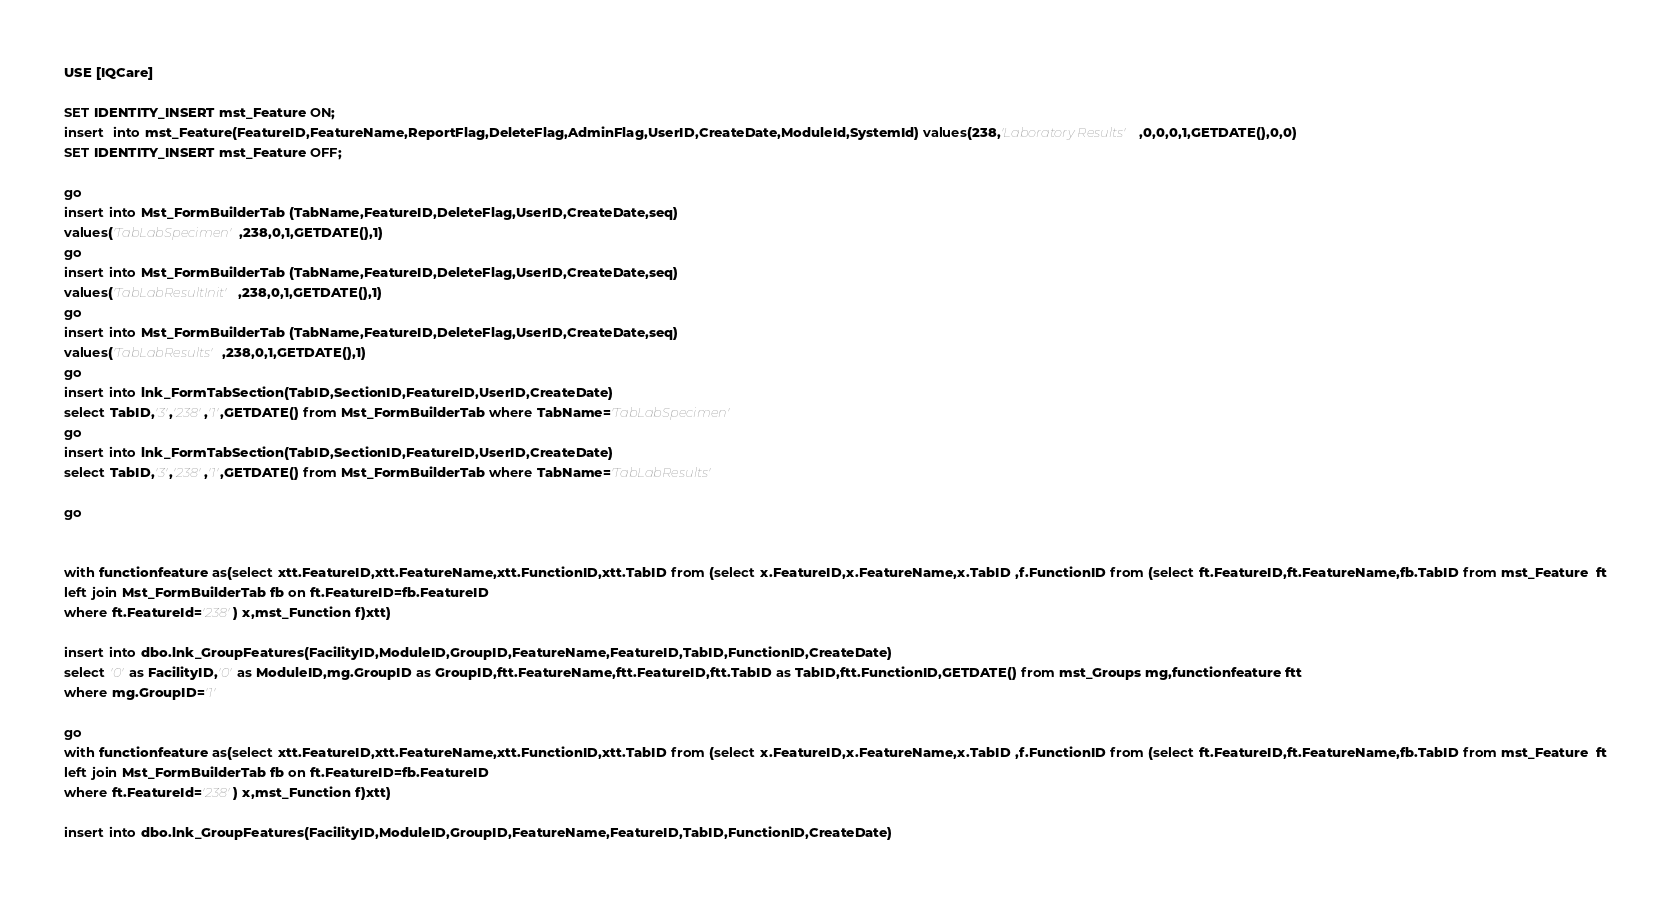<code> <loc_0><loc_0><loc_500><loc_500><_SQL_>USE [IQCare]

SET IDENTITY_INSERT mst_Feature ON;
insert  into mst_Feature(FeatureID,FeatureName,ReportFlag,DeleteFlag,AdminFlag,UserID,CreateDate,ModuleId,SystemId) values(238,'Laboratory Results',0,0,0,1,GETDATE(),0,0)
SET IDENTITY_INSERT mst_Feature OFF;

go
insert into Mst_FormBuilderTab (TabName,FeatureID,DeleteFlag,UserID,CreateDate,seq)
values('TabLabSpecimen',238,0,1,GETDATE(),1)
go
insert into Mst_FormBuilderTab (TabName,FeatureID,DeleteFlag,UserID,CreateDate,seq)
values('TabLabResultInit',238,0,1,GETDATE(),1)
go
insert into Mst_FormBuilderTab (TabName,FeatureID,DeleteFlag,UserID,CreateDate,seq)
values('TabLabResults',238,0,1,GETDATE(),1)
go
insert into lnk_FormTabSection(TabID,SectionID,FeatureID,UserID,CreateDate)
select TabID,'3','238','1',GETDATE() from Mst_FormBuilderTab where TabName='TabLabSpecimen'
go
insert into lnk_FormTabSection(TabID,SectionID,FeatureID,UserID,CreateDate)
select TabID,'3','238','1',GETDATE() from Mst_FormBuilderTab where TabName='TabLabResults'

go


with functionfeature as(select xtt.FeatureID,xtt.FeatureName,xtt.FunctionID,xtt.TabID from (select x.FeatureID,x.FeatureName,x.TabID ,f.FunctionID from (select ft.FeatureID,ft.FeatureName,fb.TabID from mst_Feature  ft
left join Mst_FormBuilderTab fb on ft.FeatureID=fb.FeatureID
where ft.FeatureId='238') x,mst_Function f)xtt)

insert into dbo.lnk_GroupFeatures(FacilityID,ModuleID,GroupID,FeatureName,FeatureID,TabID,FunctionID,CreateDate) 
select '0' as FacilityID,'0' as ModuleID,mg.GroupID as GroupID,ftt.FeatureName,ftt.FeatureID,ftt.TabID as TabID,ftt.FunctionID,GETDATE() from mst_Groups mg,functionfeature ftt
where mg.GroupID='1'

go 
with functionfeature as(select xtt.FeatureID,xtt.FeatureName,xtt.FunctionID,xtt.TabID from (select x.FeatureID,x.FeatureName,x.TabID ,f.FunctionID from (select ft.FeatureID,ft.FeatureName,fb.TabID from mst_Feature  ft
left join Mst_FormBuilderTab fb on ft.FeatureID=fb.FeatureID
where ft.FeatureId='238') x,mst_Function f)xtt)

insert into dbo.lnk_GroupFeatures(FacilityID,ModuleID,GroupID,FeatureName,FeatureID,TabID,FunctionID,CreateDate) </code> 